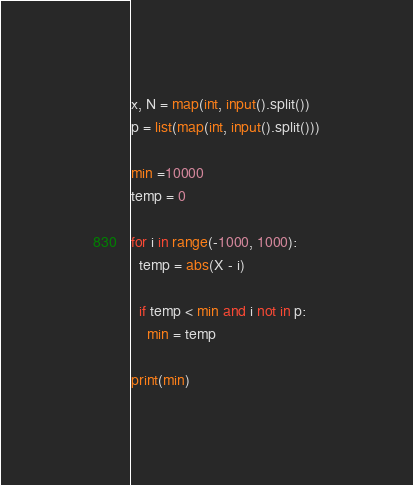Convert code to text. <code><loc_0><loc_0><loc_500><loc_500><_Python_>x, N = map(int, input().split())
p = list(map(int, input().split()))

min =10000
temp = 0

for i in range(-1000, 1000):
  temp = abs(X - i)
  
  if temp < min and i not in p:
    min = temp
    
print(min)
</code> 